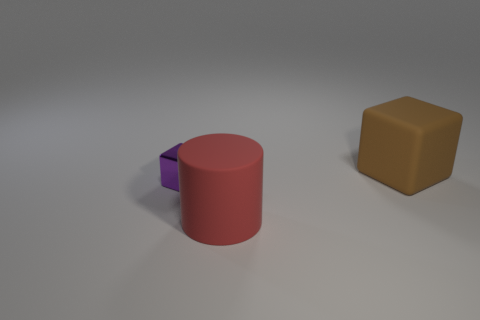Is there any other thing that has the same size as the metal object?
Give a very brief answer. No. What number of tiny blocks are the same color as the tiny metal thing?
Keep it short and to the point. 0. What is the material of the small block?
Make the answer very short. Metal. Is the size of the purple cube the same as the red object?
Offer a terse response. No. How many cylinders are either brown things or tiny objects?
Provide a succinct answer. 0. There is a matte thing that is in front of the matte object that is right of the cylinder; what color is it?
Give a very brief answer. Red. Are there fewer rubber cylinders that are left of the purple thing than cylinders that are behind the large brown rubber object?
Your answer should be very brief. No. There is a red matte object; is it the same size as the rubber object behind the small metal thing?
Ensure brevity in your answer.  Yes. The object that is both behind the large red rubber cylinder and in front of the large brown block has what shape?
Give a very brief answer. Cube. What size is the brown cube that is the same material as the large cylinder?
Offer a very short reply. Large. 